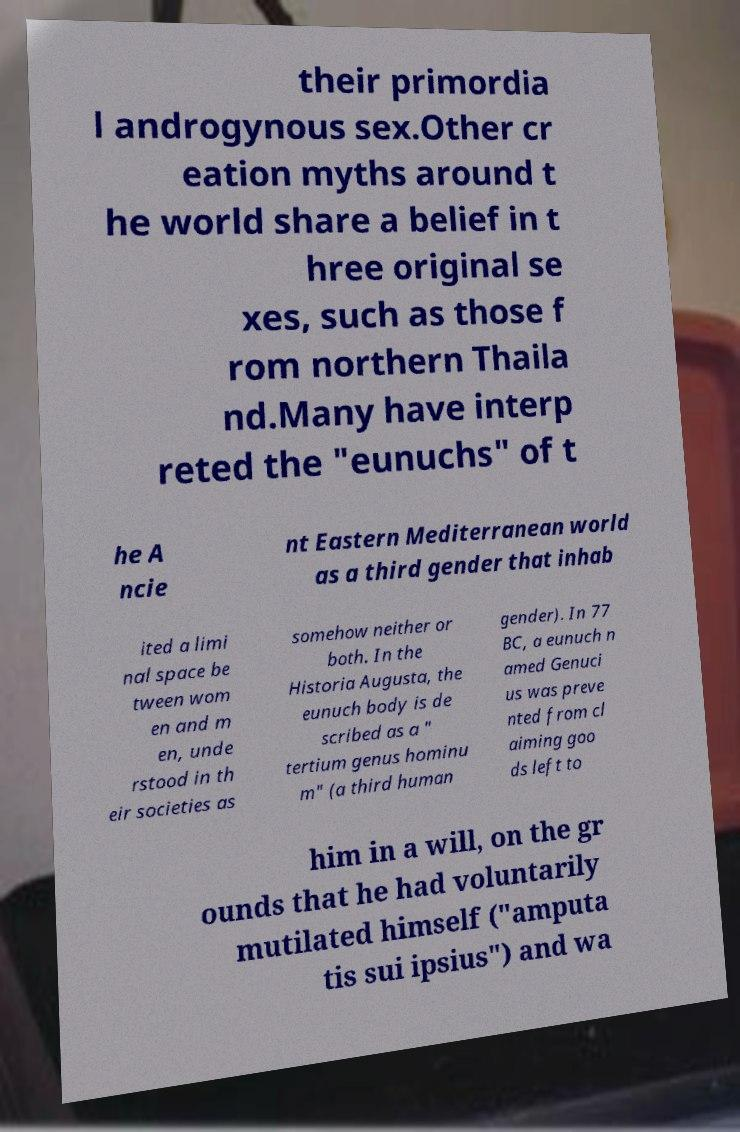What messages or text are displayed in this image? I need them in a readable, typed format. their primordia l androgynous sex.Other cr eation myths around t he world share a belief in t hree original se xes, such as those f rom northern Thaila nd.Many have interp reted the "eunuchs" of t he A ncie nt Eastern Mediterranean world as a third gender that inhab ited a limi nal space be tween wom en and m en, unde rstood in th eir societies as somehow neither or both. In the Historia Augusta, the eunuch body is de scribed as a " tertium genus hominu m" (a third human gender). In 77 BC, a eunuch n amed Genuci us was preve nted from cl aiming goo ds left to him in a will, on the gr ounds that he had voluntarily mutilated himself ("amputa tis sui ipsius") and wa 